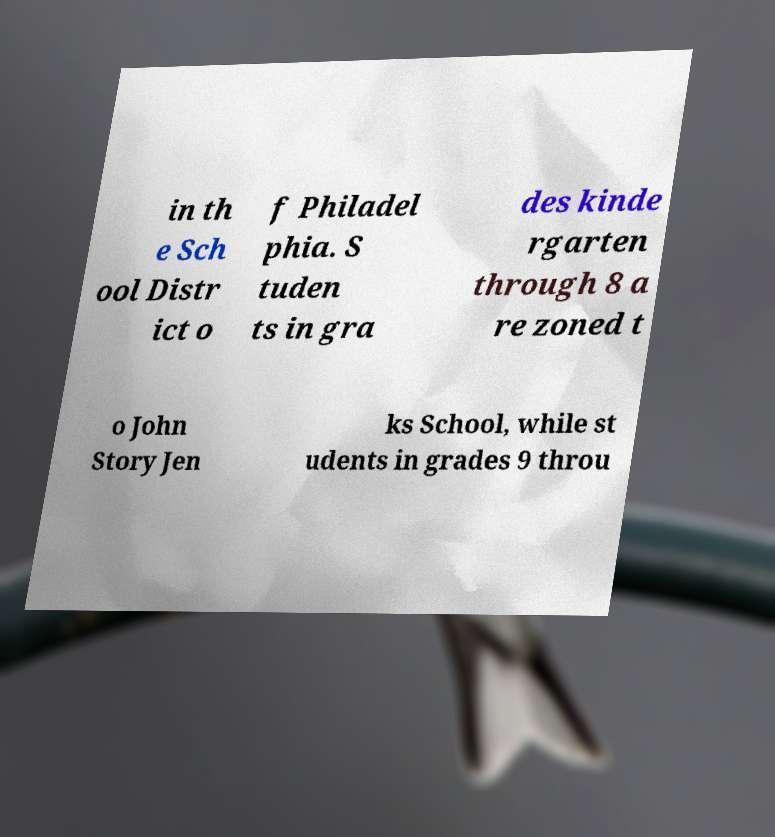Could you assist in decoding the text presented in this image and type it out clearly? in th e Sch ool Distr ict o f Philadel phia. S tuden ts in gra des kinde rgarten through 8 a re zoned t o John Story Jen ks School, while st udents in grades 9 throu 